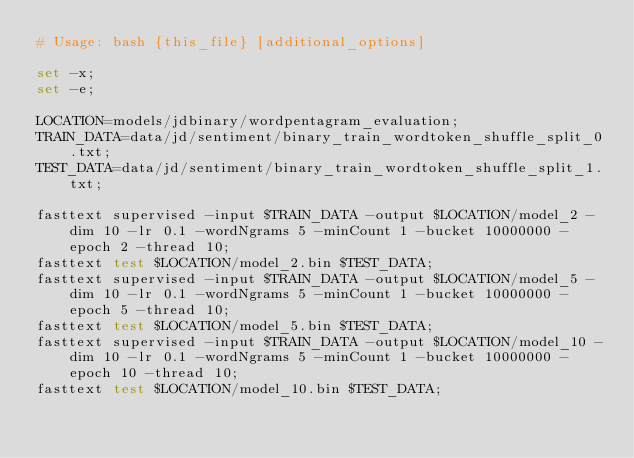<code> <loc_0><loc_0><loc_500><loc_500><_Bash_># Usage: bash {this_file} [additional_options]

set -x;
set -e;

LOCATION=models/jdbinary/wordpentagram_evaluation;
TRAIN_DATA=data/jd/sentiment/binary_train_wordtoken_shuffle_split_0.txt;
TEST_DATA=data/jd/sentiment/binary_train_wordtoken_shuffle_split_1.txt;

fasttext supervised -input $TRAIN_DATA -output $LOCATION/model_2 -dim 10 -lr 0.1 -wordNgrams 5 -minCount 1 -bucket 10000000 -epoch 2 -thread 10;
fasttext test $LOCATION/model_2.bin $TEST_DATA;
fasttext supervised -input $TRAIN_DATA -output $LOCATION/model_5 -dim 10 -lr 0.1 -wordNgrams 5 -minCount 1 -bucket 10000000 -epoch 5 -thread 10;
fasttext test $LOCATION/model_5.bin $TEST_DATA;
fasttext supervised -input $TRAIN_DATA -output $LOCATION/model_10 -dim 10 -lr 0.1 -wordNgrams 5 -minCount 1 -bucket 10000000 -epoch 10 -thread 10;
fasttext test $LOCATION/model_10.bin $TEST_DATA;
</code> 